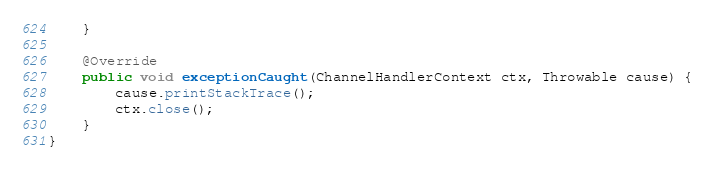Convert code to text. <code><loc_0><loc_0><loc_500><loc_500><_Java_>    }

    @Override
    public void exceptionCaught(ChannelHandlerContext ctx, Throwable cause) {
        cause.printStackTrace();
        ctx.close();
    }
}</code> 